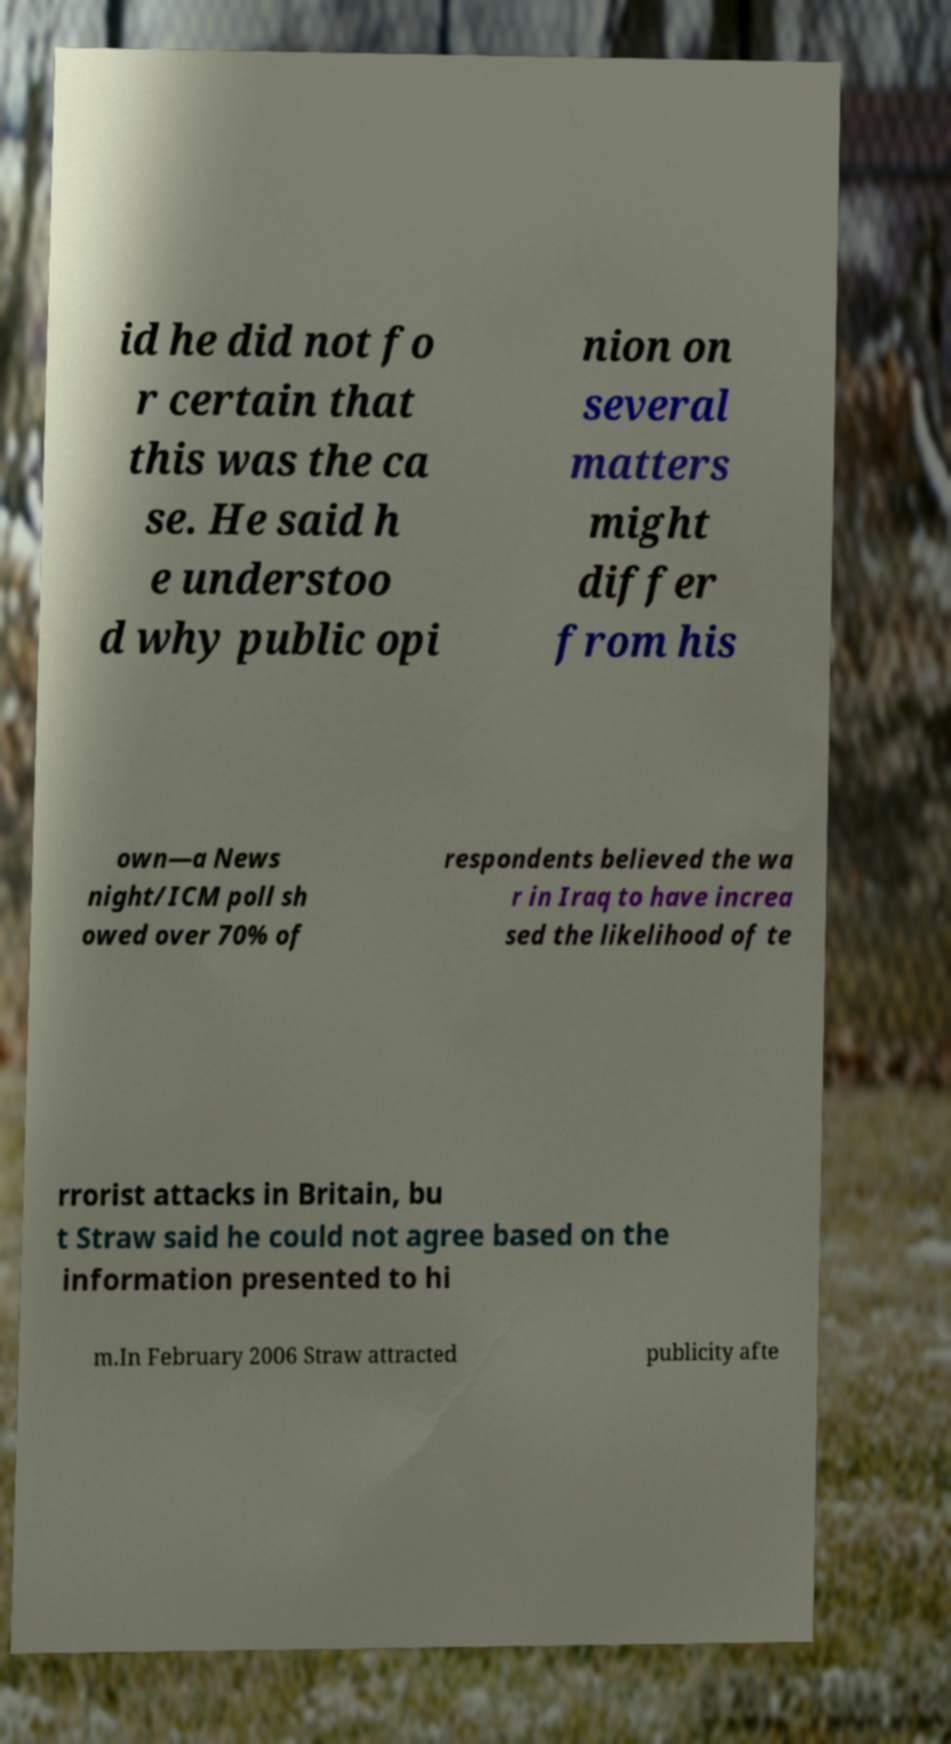Please identify and transcribe the text found in this image. id he did not fo r certain that this was the ca se. He said h e understoo d why public opi nion on several matters might differ from his own—a News night/ICM poll sh owed over 70% of respondents believed the wa r in Iraq to have increa sed the likelihood of te rrorist attacks in Britain, bu t Straw said he could not agree based on the information presented to hi m.In February 2006 Straw attracted publicity afte 